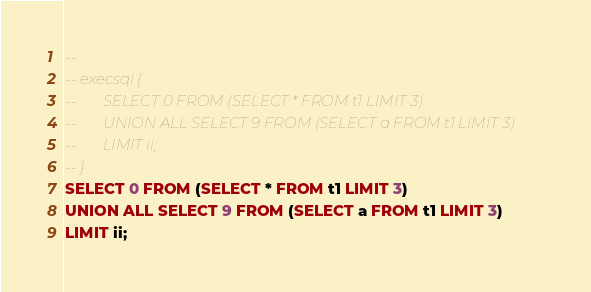Convert code to text. <code><loc_0><loc_0><loc_500><loc_500><_SQL_>-- 
-- execsql {
--       SELECT 0 FROM (SELECT * FROM t1 LIMIT 3)
--       UNION ALL SELECT 9 FROM (SELECT a FROM t1 LIMIT 3)
--       LIMIT ii;
-- }
SELECT 0 FROM (SELECT * FROM t1 LIMIT 3)
UNION ALL SELECT 9 FROM (SELECT a FROM t1 LIMIT 3)
LIMIT ii;
</code> 